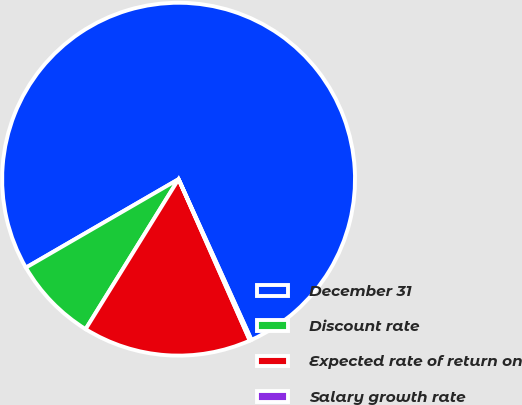Convert chart to OTSL. <chart><loc_0><loc_0><loc_500><loc_500><pie_chart><fcel>December 31<fcel>Discount rate<fcel>Expected rate of return on<fcel>Salary growth rate<nl><fcel>76.58%<fcel>7.81%<fcel>15.45%<fcel>0.16%<nl></chart> 